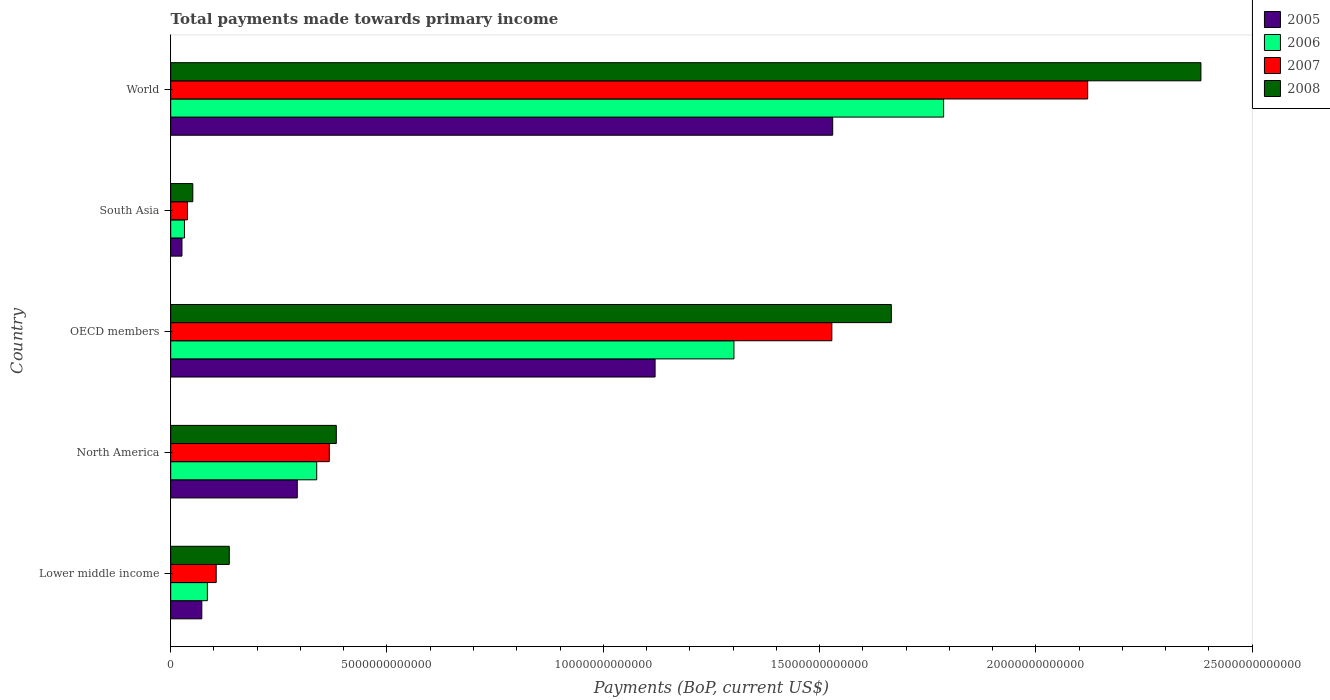How many groups of bars are there?
Offer a terse response. 5. Are the number of bars per tick equal to the number of legend labels?
Your answer should be compact. Yes. Are the number of bars on each tick of the Y-axis equal?
Ensure brevity in your answer.  Yes. How many bars are there on the 5th tick from the bottom?
Make the answer very short. 4. What is the label of the 3rd group of bars from the top?
Offer a very short reply. OECD members. What is the total payments made towards primary income in 2006 in North America?
Provide a succinct answer. 3.38e+12. Across all countries, what is the maximum total payments made towards primary income in 2006?
Your response must be concise. 1.79e+13. Across all countries, what is the minimum total payments made towards primary income in 2007?
Give a very brief answer. 3.88e+11. What is the total total payments made towards primary income in 2007 in the graph?
Offer a very short reply. 4.16e+13. What is the difference between the total payments made towards primary income in 2007 in OECD members and that in South Asia?
Offer a very short reply. 1.49e+13. What is the difference between the total payments made towards primary income in 2006 in OECD members and the total payments made towards primary income in 2007 in Lower middle income?
Your answer should be very brief. 1.20e+13. What is the average total payments made towards primary income in 2005 per country?
Offer a very short reply. 6.08e+12. What is the difference between the total payments made towards primary income in 2008 and total payments made towards primary income in 2006 in South Asia?
Provide a short and direct response. 1.93e+11. What is the ratio of the total payments made towards primary income in 2008 in North America to that in World?
Provide a short and direct response. 0.16. Is the difference between the total payments made towards primary income in 2008 in North America and South Asia greater than the difference between the total payments made towards primary income in 2006 in North America and South Asia?
Your answer should be very brief. Yes. What is the difference between the highest and the second highest total payments made towards primary income in 2005?
Offer a very short reply. 4.11e+12. What is the difference between the highest and the lowest total payments made towards primary income in 2007?
Provide a short and direct response. 2.08e+13. In how many countries, is the total payments made towards primary income in 2005 greater than the average total payments made towards primary income in 2005 taken over all countries?
Your answer should be very brief. 2. Is the sum of the total payments made towards primary income in 2005 in Lower middle income and South Asia greater than the maximum total payments made towards primary income in 2007 across all countries?
Keep it short and to the point. No. Is it the case that in every country, the sum of the total payments made towards primary income in 2008 and total payments made towards primary income in 2006 is greater than the sum of total payments made towards primary income in 2005 and total payments made towards primary income in 2007?
Keep it short and to the point. No. What does the 1st bar from the bottom in Lower middle income represents?
Keep it short and to the point. 2005. Are all the bars in the graph horizontal?
Offer a very short reply. Yes. What is the difference between two consecutive major ticks on the X-axis?
Your response must be concise. 5.00e+12. What is the title of the graph?
Offer a terse response. Total payments made towards primary income. What is the label or title of the X-axis?
Your answer should be very brief. Payments (BoP, current US$). What is the label or title of the Y-axis?
Give a very brief answer. Country. What is the Payments (BoP, current US$) of 2005 in Lower middle income?
Ensure brevity in your answer.  7.19e+11. What is the Payments (BoP, current US$) in 2006 in Lower middle income?
Make the answer very short. 8.48e+11. What is the Payments (BoP, current US$) in 2007 in Lower middle income?
Provide a succinct answer. 1.05e+12. What is the Payments (BoP, current US$) of 2008 in Lower middle income?
Provide a short and direct response. 1.35e+12. What is the Payments (BoP, current US$) of 2005 in North America?
Your answer should be compact. 2.93e+12. What is the Payments (BoP, current US$) in 2006 in North America?
Your response must be concise. 3.38e+12. What is the Payments (BoP, current US$) of 2007 in North America?
Make the answer very short. 3.67e+12. What is the Payments (BoP, current US$) of 2008 in North America?
Keep it short and to the point. 3.83e+12. What is the Payments (BoP, current US$) in 2005 in OECD members?
Offer a terse response. 1.12e+13. What is the Payments (BoP, current US$) in 2006 in OECD members?
Make the answer very short. 1.30e+13. What is the Payments (BoP, current US$) of 2007 in OECD members?
Your response must be concise. 1.53e+13. What is the Payments (BoP, current US$) in 2008 in OECD members?
Keep it short and to the point. 1.67e+13. What is the Payments (BoP, current US$) in 2005 in South Asia?
Make the answer very short. 2.61e+11. What is the Payments (BoP, current US$) of 2006 in South Asia?
Make the answer very short. 3.18e+11. What is the Payments (BoP, current US$) in 2007 in South Asia?
Your response must be concise. 3.88e+11. What is the Payments (BoP, current US$) in 2008 in South Asia?
Ensure brevity in your answer.  5.11e+11. What is the Payments (BoP, current US$) in 2005 in World?
Provide a short and direct response. 1.53e+13. What is the Payments (BoP, current US$) in 2006 in World?
Make the answer very short. 1.79e+13. What is the Payments (BoP, current US$) of 2007 in World?
Provide a short and direct response. 2.12e+13. What is the Payments (BoP, current US$) in 2008 in World?
Give a very brief answer. 2.38e+13. Across all countries, what is the maximum Payments (BoP, current US$) of 2005?
Make the answer very short. 1.53e+13. Across all countries, what is the maximum Payments (BoP, current US$) of 2006?
Give a very brief answer. 1.79e+13. Across all countries, what is the maximum Payments (BoP, current US$) in 2007?
Give a very brief answer. 2.12e+13. Across all countries, what is the maximum Payments (BoP, current US$) of 2008?
Your answer should be compact. 2.38e+13. Across all countries, what is the minimum Payments (BoP, current US$) in 2005?
Offer a terse response. 2.61e+11. Across all countries, what is the minimum Payments (BoP, current US$) in 2006?
Your answer should be very brief. 3.18e+11. Across all countries, what is the minimum Payments (BoP, current US$) of 2007?
Keep it short and to the point. 3.88e+11. Across all countries, what is the minimum Payments (BoP, current US$) in 2008?
Keep it short and to the point. 5.11e+11. What is the total Payments (BoP, current US$) in 2005 in the graph?
Keep it short and to the point. 3.04e+13. What is the total Payments (BoP, current US$) in 2006 in the graph?
Offer a very short reply. 3.54e+13. What is the total Payments (BoP, current US$) in 2007 in the graph?
Your answer should be very brief. 4.16e+13. What is the total Payments (BoP, current US$) of 2008 in the graph?
Your response must be concise. 4.62e+13. What is the difference between the Payments (BoP, current US$) of 2005 in Lower middle income and that in North America?
Your answer should be compact. -2.21e+12. What is the difference between the Payments (BoP, current US$) of 2006 in Lower middle income and that in North America?
Offer a very short reply. -2.53e+12. What is the difference between the Payments (BoP, current US$) of 2007 in Lower middle income and that in North America?
Make the answer very short. -2.61e+12. What is the difference between the Payments (BoP, current US$) of 2008 in Lower middle income and that in North America?
Offer a very short reply. -2.47e+12. What is the difference between the Payments (BoP, current US$) of 2005 in Lower middle income and that in OECD members?
Ensure brevity in your answer.  -1.05e+13. What is the difference between the Payments (BoP, current US$) of 2006 in Lower middle income and that in OECD members?
Your response must be concise. -1.22e+13. What is the difference between the Payments (BoP, current US$) of 2007 in Lower middle income and that in OECD members?
Provide a succinct answer. -1.42e+13. What is the difference between the Payments (BoP, current US$) of 2008 in Lower middle income and that in OECD members?
Keep it short and to the point. -1.53e+13. What is the difference between the Payments (BoP, current US$) in 2005 in Lower middle income and that in South Asia?
Your answer should be compact. 4.59e+11. What is the difference between the Payments (BoP, current US$) in 2006 in Lower middle income and that in South Asia?
Offer a terse response. 5.30e+11. What is the difference between the Payments (BoP, current US$) in 2007 in Lower middle income and that in South Asia?
Keep it short and to the point. 6.64e+11. What is the difference between the Payments (BoP, current US$) in 2008 in Lower middle income and that in South Asia?
Your answer should be very brief. 8.43e+11. What is the difference between the Payments (BoP, current US$) of 2005 in Lower middle income and that in World?
Offer a terse response. -1.46e+13. What is the difference between the Payments (BoP, current US$) of 2006 in Lower middle income and that in World?
Your answer should be compact. -1.70e+13. What is the difference between the Payments (BoP, current US$) in 2007 in Lower middle income and that in World?
Offer a terse response. -2.01e+13. What is the difference between the Payments (BoP, current US$) of 2008 in Lower middle income and that in World?
Provide a short and direct response. -2.25e+13. What is the difference between the Payments (BoP, current US$) of 2005 in North America and that in OECD members?
Your answer should be very brief. -8.27e+12. What is the difference between the Payments (BoP, current US$) in 2006 in North America and that in OECD members?
Provide a short and direct response. -9.65e+12. What is the difference between the Payments (BoP, current US$) in 2007 in North America and that in OECD members?
Your answer should be very brief. -1.16e+13. What is the difference between the Payments (BoP, current US$) in 2008 in North America and that in OECD members?
Provide a short and direct response. -1.28e+13. What is the difference between the Payments (BoP, current US$) of 2005 in North America and that in South Asia?
Ensure brevity in your answer.  2.67e+12. What is the difference between the Payments (BoP, current US$) in 2006 in North America and that in South Asia?
Offer a very short reply. 3.06e+12. What is the difference between the Payments (BoP, current US$) of 2007 in North America and that in South Asia?
Your answer should be very brief. 3.28e+12. What is the difference between the Payments (BoP, current US$) of 2008 in North America and that in South Asia?
Your answer should be very brief. 3.32e+12. What is the difference between the Payments (BoP, current US$) of 2005 in North America and that in World?
Provide a succinct answer. -1.24e+13. What is the difference between the Payments (BoP, current US$) in 2006 in North America and that in World?
Provide a succinct answer. -1.45e+13. What is the difference between the Payments (BoP, current US$) of 2007 in North America and that in World?
Provide a short and direct response. -1.75e+13. What is the difference between the Payments (BoP, current US$) in 2008 in North America and that in World?
Offer a terse response. -2.00e+13. What is the difference between the Payments (BoP, current US$) in 2005 in OECD members and that in South Asia?
Make the answer very short. 1.09e+13. What is the difference between the Payments (BoP, current US$) in 2006 in OECD members and that in South Asia?
Your answer should be very brief. 1.27e+13. What is the difference between the Payments (BoP, current US$) of 2007 in OECD members and that in South Asia?
Make the answer very short. 1.49e+13. What is the difference between the Payments (BoP, current US$) in 2008 in OECD members and that in South Asia?
Your answer should be compact. 1.61e+13. What is the difference between the Payments (BoP, current US$) in 2005 in OECD members and that in World?
Offer a terse response. -4.11e+12. What is the difference between the Payments (BoP, current US$) of 2006 in OECD members and that in World?
Your response must be concise. -4.85e+12. What is the difference between the Payments (BoP, current US$) of 2007 in OECD members and that in World?
Make the answer very short. -5.91e+12. What is the difference between the Payments (BoP, current US$) of 2008 in OECD members and that in World?
Give a very brief answer. -7.16e+12. What is the difference between the Payments (BoP, current US$) in 2005 in South Asia and that in World?
Your response must be concise. -1.50e+13. What is the difference between the Payments (BoP, current US$) in 2006 in South Asia and that in World?
Your answer should be very brief. -1.75e+13. What is the difference between the Payments (BoP, current US$) in 2007 in South Asia and that in World?
Keep it short and to the point. -2.08e+13. What is the difference between the Payments (BoP, current US$) of 2008 in South Asia and that in World?
Keep it short and to the point. -2.33e+13. What is the difference between the Payments (BoP, current US$) of 2005 in Lower middle income and the Payments (BoP, current US$) of 2006 in North America?
Your response must be concise. -2.66e+12. What is the difference between the Payments (BoP, current US$) in 2005 in Lower middle income and the Payments (BoP, current US$) in 2007 in North America?
Your answer should be compact. -2.95e+12. What is the difference between the Payments (BoP, current US$) of 2005 in Lower middle income and the Payments (BoP, current US$) of 2008 in North America?
Make the answer very short. -3.11e+12. What is the difference between the Payments (BoP, current US$) of 2006 in Lower middle income and the Payments (BoP, current US$) of 2007 in North America?
Offer a very short reply. -2.82e+12. What is the difference between the Payments (BoP, current US$) of 2006 in Lower middle income and the Payments (BoP, current US$) of 2008 in North America?
Provide a succinct answer. -2.98e+12. What is the difference between the Payments (BoP, current US$) of 2007 in Lower middle income and the Payments (BoP, current US$) of 2008 in North America?
Provide a short and direct response. -2.78e+12. What is the difference between the Payments (BoP, current US$) in 2005 in Lower middle income and the Payments (BoP, current US$) in 2006 in OECD members?
Your answer should be very brief. -1.23e+13. What is the difference between the Payments (BoP, current US$) of 2005 in Lower middle income and the Payments (BoP, current US$) of 2007 in OECD members?
Offer a very short reply. -1.46e+13. What is the difference between the Payments (BoP, current US$) of 2005 in Lower middle income and the Payments (BoP, current US$) of 2008 in OECD members?
Make the answer very short. -1.59e+13. What is the difference between the Payments (BoP, current US$) of 2006 in Lower middle income and the Payments (BoP, current US$) of 2007 in OECD members?
Your answer should be very brief. -1.44e+13. What is the difference between the Payments (BoP, current US$) of 2006 in Lower middle income and the Payments (BoP, current US$) of 2008 in OECD members?
Make the answer very short. -1.58e+13. What is the difference between the Payments (BoP, current US$) of 2007 in Lower middle income and the Payments (BoP, current US$) of 2008 in OECD members?
Make the answer very short. -1.56e+13. What is the difference between the Payments (BoP, current US$) of 2005 in Lower middle income and the Payments (BoP, current US$) of 2006 in South Asia?
Ensure brevity in your answer.  4.01e+11. What is the difference between the Payments (BoP, current US$) in 2005 in Lower middle income and the Payments (BoP, current US$) in 2007 in South Asia?
Offer a terse response. 3.32e+11. What is the difference between the Payments (BoP, current US$) in 2005 in Lower middle income and the Payments (BoP, current US$) in 2008 in South Asia?
Provide a short and direct response. 2.08e+11. What is the difference between the Payments (BoP, current US$) of 2006 in Lower middle income and the Payments (BoP, current US$) of 2007 in South Asia?
Your answer should be compact. 4.60e+11. What is the difference between the Payments (BoP, current US$) in 2006 in Lower middle income and the Payments (BoP, current US$) in 2008 in South Asia?
Offer a terse response. 3.37e+11. What is the difference between the Payments (BoP, current US$) of 2007 in Lower middle income and the Payments (BoP, current US$) of 2008 in South Asia?
Your answer should be compact. 5.41e+11. What is the difference between the Payments (BoP, current US$) of 2005 in Lower middle income and the Payments (BoP, current US$) of 2006 in World?
Your response must be concise. -1.71e+13. What is the difference between the Payments (BoP, current US$) in 2005 in Lower middle income and the Payments (BoP, current US$) in 2007 in World?
Offer a very short reply. -2.05e+13. What is the difference between the Payments (BoP, current US$) in 2005 in Lower middle income and the Payments (BoP, current US$) in 2008 in World?
Your response must be concise. -2.31e+13. What is the difference between the Payments (BoP, current US$) of 2006 in Lower middle income and the Payments (BoP, current US$) of 2007 in World?
Provide a succinct answer. -2.04e+13. What is the difference between the Payments (BoP, current US$) in 2006 in Lower middle income and the Payments (BoP, current US$) in 2008 in World?
Your response must be concise. -2.30e+13. What is the difference between the Payments (BoP, current US$) of 2007 in Lower middle income and the Payments (BoP, current US$) of 2008 in World?
Your response must be concise. -2.28e+13. What is the difference between the Payments (BoP, current US$) of 2005 in North America and the Payments (BoP, current US$) of 2006 in OECD members?
Your answer should be compact. -1.01e+13. What is the difference between the Payments (BoP, current US$) of 2005 in North America and the Payments (BoP, current US$) of 2007 in OECD members?
Ensure brevity in your answer.  -1.24e+13. What is the difference between the Payments (BoP, current US$) of 2005 in North America and the Payments (BoP, current US$) of 2008 in OECD members?
Provide a succinct answer. -1.37e+13. What is the difference between the Payments (BoP, current US$) of 2006 in North America and the Payments (BoP, current US$) of 2007 in OECD members?
Provide a succinct answer. -1.19e+13. What is the difference between the Payments (BoP, current US$) of 2006 in North America and the Payments (BoP, current US$) of 2008 in OECD members?
Offer a very short reply. -1.33e+13. What is the difference between the Payments (BoP, current US$) in 2007 in North America and the Payments (BoP, current US$) in 2008 in OECD members?
Offer a very short reply. -1.30e+13. What is the difference between the Payments (BoP, current US$) of 2005 in North America and the Payments (BoP, current US$) of 2006 in South Asia?
Offer a very short reply. 2.61e+12. What is the difference between the Payments (BoP, current US$) of 2005 in North America and the Payments (BoP, current US$) of 2007 in South Asia?
Your response must be concise. 2.54e+12. What is the difference between the Payments (BoP, current US$) of 2005 in North America and the Payments (BoP, current US$) of 2008 in South Asia?
Give a very brief answer. 2.41e+12. What is the difference between the Payments (BoP, current US$) in 2006 in North America and the Payments (BoP, current US$) in 2007 in South Asia?
Keep it short and to the point. 2.99e+12. What is the difference between the Payments (BoP, current US$) in 2006 in North America and the Payments (BoP, current US$) in 2008 in South Asia?
Give a very brief answer. 2.86e+12. What is the difference between the Payments (BoP, current US$) in 2007 in North America and the Payments (BoP, current US$) in 2008 in South Asia?
Offer a terse response. 3.15e+12. What is the difference between the Payments (BoP, current US$) in 2005 in North America and the Payments (BoP, current US$) in 2006 in World?
Make the answer very short. -1.49e+13. What is the difference between the Payments (BoP, current US$) in 2005 in North America and the Payments (BoP, current US$) in 2007 in World?
Your response must be concise. -1.83e+13. What is the difference between the Payments (BoP, current US$) of 2005 in North America and the Payments (BoP, current US$) of 2008 in World?
Give a very brief answer. -2.09e+13. What is the difference between the Payments (BoP, current US$) of 2006 in North America and the Payments (BoP, current US$) of 2007 in World?
Keep it short and to the point. -1.78e+13. What is the difference between the Payments (BoP, current US$) in 2006 in North America and the Payments (BoP, current US$) in 2008 in World?
Your response must be concise. -2.04e+13. What is the difference between the Payments (BoP, current US$) in 2007 in North America and the Payments (BoP, current US$) in 2008 in World?
Keep it short and to the point. -2.01e+13. What is the difference between the Payments (BoP, current US$) of 2005 in OECD members and the Payments (BoP, current US$) of 2006 in South Asia?
Offer a terse response. 1.09e+13. What is the difference between the Payments (BoP, current US$) of 2005 in OECD members and the Payments (BoP, current US$) of 2007 in South Asia?
Offer a terse response. 1.08e+13. What is the difference between the Payments (BoP, current US$) of 2005 in OECD members and the Payments (BoP, current US$) of 2008 in South Asia?
Your response must be concise. 1.07e+13. What is the difference between the Payments (BoP, current US$) in 2006 in OECD members and the Payments (BoP, current US$) in 2007 in South Asia?
Your response must be concise. 1.26e+13. What is the difference between the Payments (BoP, current US$) of 2006 in OECD members and the Payments (BoP, current US$) of 2008 in South Asia?
Ensure brevity in your answer.  1.25e+13. What is the difference between the Payments (BoP, current US$) of 2007 in OECD members and the Payments (BoP, current US$) of 2008 in South Asia?
Provide a short and direct response. 1.48e+13. What is the difference between the Payments (BoP, current US$) in 2005 in OECD members and the Payments (BoP, current US$) in 2006 in World?
Your answer should be compact. -6.67e+12. What is the difference between the Payments (BoP, current US$) of 2005 in OECD members and the Payments (BoP, current US$) of 2007 in World?
Your response must be concise. -1.00e+13. What is the difference between the Payments (BoP, current US$) in 2005 in OECD members and the Payments (BoP, current US$) in 2008 in World?
Your answer should be very brief. -1.26e+13. What is the difference between the Payments (BoP, current US$) in 2006 in OECD members and the Payments (BoP, current US$) in 2007 in World?
Ensure brevity in your answer.  -8.18e+12. What is the difference between the Payments (BoP, current US$) of 2006 in OECD members and the Payments (BoP, current US$) of 2008 in World?
Give a very brief answer. -1.08e+13. What is the difference between the Payments (BoP, current US$) in 2007 in OECD members and the Payments (BoP, current US$) in 2008 in World?
Ensure brevity in your answer.  -8.53e+12. What is the difference between the Payments (BoP, current US$) in 2005 in South Asia and the Payments (BoP, current US$) in 2006 in World?
Ensure brevity in your answer.  -1.76e+13. What is the difference between the Payments (BoP, current US$) of 2005 in South Asia and the Payments (BoP, current US$) of 2007 in World?
Offer a terse response. -2.09e+13. What is the difference between the Payments (BoP, current US$) in 2005 in South Asia and the Payments (BoP, current US$) in 2008 in World?
Your answer should be very brief. -2.36e+13. What is the difference between the Payments (BoP, current US$) of 2006 in South Asia and the Payments (BoP, current US$) of 2007 in World?
Ensure brevity in your answer.  -2.09e+13. What is the difference between the Payments (BoP, current US$) of 2006 in South Asia and the Payments (BoP, current US$) of 2008 in World?
Make the answer very short. -2.35e+13. What is the difference between the Payments (BoP, current US$) in 2007 in South Asia and the Payments (BoP, current US$) in 2008 in World?
Offer a terse response. -2.34e+13. What is the average Payments (BoP, current US$) in 2005 per country?
Your answer should be very brief. 6.08e+12. What is the average Payments (BoP, current US$) of 2006 per country?
Your response must be concise. 7.09e+12. What is the average Payments (BoP, current US$) in 2007 per country?
Your answer should be very brief. 8.32e+12. What is the average Payments (BoP, current US$) of 2008 per country?
Offer a very short reply. 9.23e+12. What is the difference between the Payments (BoP, current US$) of 2005 and Payments (BoP, current US$) of 2006 in Lower middle income?
Keep it short and to the point. -1.29e+11. What is the difference between the Payments (BoP, current US$) in 2005 and Payments (BoP, current US$) in 2007 in Lower middle income?
Give a very brief answer. -3.33e+11. What is the difference between the Payments (BoP, current US$) of 2005 and Payments (BoP, current US$) of 2008 in Lower middle income?
Your response must be concise. -6.35e+11. What is the difference between the Payments (BoP, current US$) in 2006 and Payments (BoP, current US$) in 2007 in Lower middle income?
Your answer should be compact. -2.04e+11. What is the difference between the Payments (BoP, current US$) in 2006 and Payments (BoP, current US$) in 2008 in Lower middle income?
Make the answer very short. -5.07e+11. What is the difference between the Payments (BoP, current US$) of 2007 and Payments (BoP, current US$) of 2008 in Lower middle income?
Make the answer very short. -3.03e+11. What is the difference between the Payments (BoP, current US$) in 2005 and Payments (BoP, current US$) in 2006 in North America?
Keep it short and to the point. -4.49e+11. What is the difference between the Payments (BoP, current US$) in 2005 and Payments (BoP, current US$) in 2007 in North America?
Your answer should be very brief. -7.40e+11. What is the difference between the Payments (BoP, current US$) of 2005 and Payments (BoP, current US$) of 2008 in North America?
Provide a short and direct response. -9.02e+11. What is the difference between the Payments (BoP, current US$) of 2006 and Payments (BoP, current US$) of 2007 in North America?
Your response must be concise. -2.91e+11. What is the difference between the Payments (BoP, current US$) in 2006 and Payments (BoP, current US$) in 2008 in North America?
Provide a succinct answer. -4.53e+11. What is the difference between the Payments (BoP, current US$) of 2007 and Payments (BoP, current US$) of 2008 in North America?
Ensure brevity in your answer.  -1.62e+11. What is the difference between the Payments (BoP, current US$) in 2005 and Payments (BoP, current US$) in 2006 in OECD members?
Offer a very short reply. -1.82e+12. What is the difference between the Payments (BoP, current US$) in 2005 and Payments (BoP, current US$) in 2007 in OECD members?
Give a very brief answer. -4.09e+12. What is the difference between the Payments (BoP, current US$) in 2005 and Payments (BoP, current US$) in 2008 in OECD members?
Offer a terse response. -5.46e+12. What is the difference between the Payments (BoP, current US$) of 2006 and Payments (BoP, current US$) of 2007 in OECD members?
Offer a terse response. -2.26e+12. What is the difference between the Payments (BoP, current US$) in 2006 and Payments (BoP, current US$) in 2008 in OECD members?
Give a very brief answer. -3.64e+12. What is the difference between the Payments (BoP, current US$) in 2007 and Payments (BoP, current US$) in 2008 in OECD members?
Give a very brief answer. -1.38e+12. What is the difference between the Payments (BoP, current US$) in 2005 and Payments (BoP, current US$) in 2006 in South Asia?
Your answer should be very brief. -5.75e+1. What is the difference between the Payments (BoP, current US$) in 2005 and Payments (BoP, current US$) in 2007 in South Asia?
Your answer should be very brief. -1.27e+11. What is the difference between the Payments (BoP, current US$) in 2005 and Payments (BoP, current US$) in 2008 in South Asia?
Make the answer very short. -2.51e+11. What is the difference between the Payments (BoP, current US$) in 2006 and Payments (BoP, current US$) in 2007 in South Asia?
Your answer should be compact. -6.95e+1. What is the difference between the Payments (BoP, current US$) of 2006 and Payments (BoP, current US$) of 2008 in South Asia?
Keep it short and to the point. -1.93e+11. What is the difference between the Payments (BoP, current US$) in 2007 and Payments (BoP, current US$) in 2008 in South Asia?
Make the answer very short. -1.24e+11. What is the difference between the Payments (BoP, current US$) of 2005 and Payments (BoP, current US$) of 2006 in World?
Your response must be concise. -2.56e+12. What is the difference between the Payments (BoP, current US$) in 2005 and Payments (BoP, current US$) in 2007 in World?
Provide a short and direct response. -5.89e+12. What is the difference between the Payments (BoP, current US$) in 2005 and Payments (BoP, current US$) in 2008 in World?
Offer a terse response. -8.51e+12. What is the difference between the Payments (BoP, current US$) of 2006 and Payments (BoP, current US$) of 2007 in World?
Your response must be concise. -3.33e+12. What is the difference between the Payments (BoP, current US$) in 2006 and Payments (BoP, current US$) in 2008 in World?
Offer a very short reply. -5.95e+12. What is the difference between the Payments (BoP, current US$) of 2007 and Payments (BoP, current US$) of 2008 in World?
Keep it short and to the point. -2.62e+12. What is the ratio of the Payments (BoP, current US$) of 2005 in Lower middle income to that in North America?
Provide a succinct answer. 0.25. What is the ratio of the Payments (BoP, current US$) in 2006 in Lower middle income to that in North America?
Provide a succinct answer. 0.25. What is the ratio of the Payments (BoP, current US$) in 2007 in Lower middle income to that in North America?
Your answer should be very brief. 0.29. What is the ratio of the Payments (BoP, current US$) of 2008 in Lower middle income to that in North America?
Your answer should be very brief. 0.35. What is the ratio of the Payments (BoP, current US$) of 2005 in Lower middle income to that in OECD members?
Your response must be concise. 0.06. What is the ratio of the Payments (BoP, current US$) in 2006 in Lower middle income to that in OECD members?
Your response must be concise. 0.07. What is the ratio of the Payments (BoP, current US$) in 2007 in Lower middle income to that in OECD members?
Your answer should be very brief. 0.07. What is the ratio of the Payments (BoP, current US$) in 2008 in Lower middle income to that in OECD members?
Keep it short and to the point. 0.08. What is the ratio of the Payments (BoP, current US$) in 2005 in Lower middle income to that in South Asia?
Provide a short and direct response. 2.76. What is the ratio of the Payments (BoP, current US$) in 2006 in Lower middle income to that in South Asia?
Your answer should be compact. 2.67. What is the ratio of the Payments (BoP, current US$) of 2007 in Lower middle income to that in South Asia?
Keep it short and to the point. 2.71. What is the ratio of the Payments (BoP, current US$) in 2008 in Lower middle income to that in South Asia?
Your answer should be very brief. 2.65. What is the ratio of the Payments (BoP, current US$) in 2005 in Lower middle income to that in World?
Your answer should be very brief. 0.05. What is the ratio of the Payments (BoP, current US$) of 2006 in Lower middle income to that in World?
Provide a short and direct response. 0.05. What is the ratio of the Payments (BoP, current US$) of 2007 in Lower middle income to that in World?
Your answer should be compact. 0.05. What is the ratio of the Payments (BoP, current US$) in 2008 in Lower middle income to that in World?
Provide a succinct answer. 0.06. What is the ratio of the Payments (BoP, current US$) of 2005 in North America to that in OECD members?
Offer a terse response. 0.26. What is the ratio of the Payments (BoP, current US$) in 2006 in North America to that in OECD members?
Make the answer very short. 0.26. What is the ratio of the Payments (BoP, current US$) in 2007 in North America to that in OECD members?
Keep it short and to the point. 0.24. What is the ratio of the Payments (BoP, current US$) of 2008 in North America to that in OECD members?
Provide a short and direct response. 0.23. What is the ratio of the Payments (BoP, current US$) in 2005 in North America to that in South Asia?
Keep it short and to the point. 11.23. What is the ratio of the Payments (BoP, current US$) of 2006 in North America to that in South Asia?
Offer a terse response. 10.61. What is the ratio of the Payments (BoP, current US$) in 2007 in North America to that in South Asia?
Ensure brevity in your answer.  9.46. What is the ratio of the Payments (BoP, current US$) in 2008 in North America to that in South Asia?
Make the answer very short. 7.49. What is the ratio of the Payments (BoP, current US$) in 2005 in North America to that in World?
Your answer should be very brief. 0.19. What is the ratio of the Payments (BoP, current US$) in 2006 in North America to that in World?
Ensure brevity in your answer.  0.19. What is the ratio of the Payments (BoP, current US$) in 2007 in North America to that in World?
Your answer should be compact. 0.17. What is the ratio of the Payments (BoP, current US$) of 2008 in North America to that in World?
Your response must be concise. 0.16. What is the ratio of the Payments (BoP, current US$) of 2005 in OECD members to that in South Asia?
Give a very brief answer. 42.99. What is the ratio of the Payments (BoP, current US$) of 2006 in OECD members to that in South Asia?
Provide a short and direct response. 40.95. What is the ratio of the Payments (BoP, current US$) of 2007 in OECD members to that in South Asia?
Your answer should be very brief. 39.44. What is the ratio of the Payments (BoP, current US$) of 2008 in OECD members to that in South Asia?
Your answer should be very brief. 32.59. What is the ratio of the Payments (BoP, current US$) of 2005 in OECD members to that in World?
Make the answer very short. 0.73. What is the ratio of the Payments (BoP, current US$) of 2006 in OECD members to that in World?
Provide a short and direct response. 0.73. What is the ratio of the Payments (BoP, current US$) of 2007 in OECD members to that in World?
Provide a succinct answer. 0.72. What is the ratio of the Payments (BoP, current US$) in 2008 in OECD members to that in World?
Your answer should be very brief. 0.7. What is the ratio of the Payments (BoP, current US$) of 2005 in South Asia to that in World?
Your response must be concise. 0.02. What is the ratio of the Payments (BoP, current US$) in 2006 in South Asia to that in World?
Keep it short and to the point. 0.02. What is the ratio of the Payments (BoP, current US$) of 2007 in South Asia to that in World?
Ensure brevity in your answer.  0.02. What is the ratio of the Payments (BoP, current US$) in 2008 in South Asia to that in World?
Your response must be concise. 0.02. What is the difference between the highest and the second highest Payments (BoP, current US$) of 2005?
Provide a short and direct response. 4.11e+12. What is the difference between the highest and the second highest Payments (BoP, current US$) of 2006?
Provide a short and direct response. 4.85e+12. What is the difference between the highest and the second highest Payments (BoP, current US$) of 2007?
Offer a very short reply. 5.91e+12. What is the difference between the highest and the second highest Payments (BoP, current US$) in 2008?
Your answer should be very brief. 7.16e+12. What is the difference between the highest and the lowest Payments (BoP, current US$) of 2005?
Your response must be concise. 1.50e+13. What is the difference between the highest and the lowest Payments (BoP, current US$) of 2006?
Provide a succinct answer. 1.75e+13. What is the difference between the highest and the lowest Payments (BoP, current US$) in 2007?
Your answer should be very brief. 2.08e+13. What is the difference between the highest and the lowest Payments (BoP, current US$) of 2008?
Make the answer very short. 2.33e+13. 